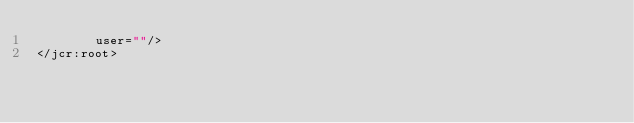<code> <loc_0><loc_0><loc_500><loc_500><_XML_>        user=""/>
</jcr:root>
</code> 